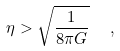<formula> <loc_0><loc_0><loc_500><loc_500>\eta > \sqrt { \frac { 1 } { 8 \pi G } } \ \ ,</formula> 